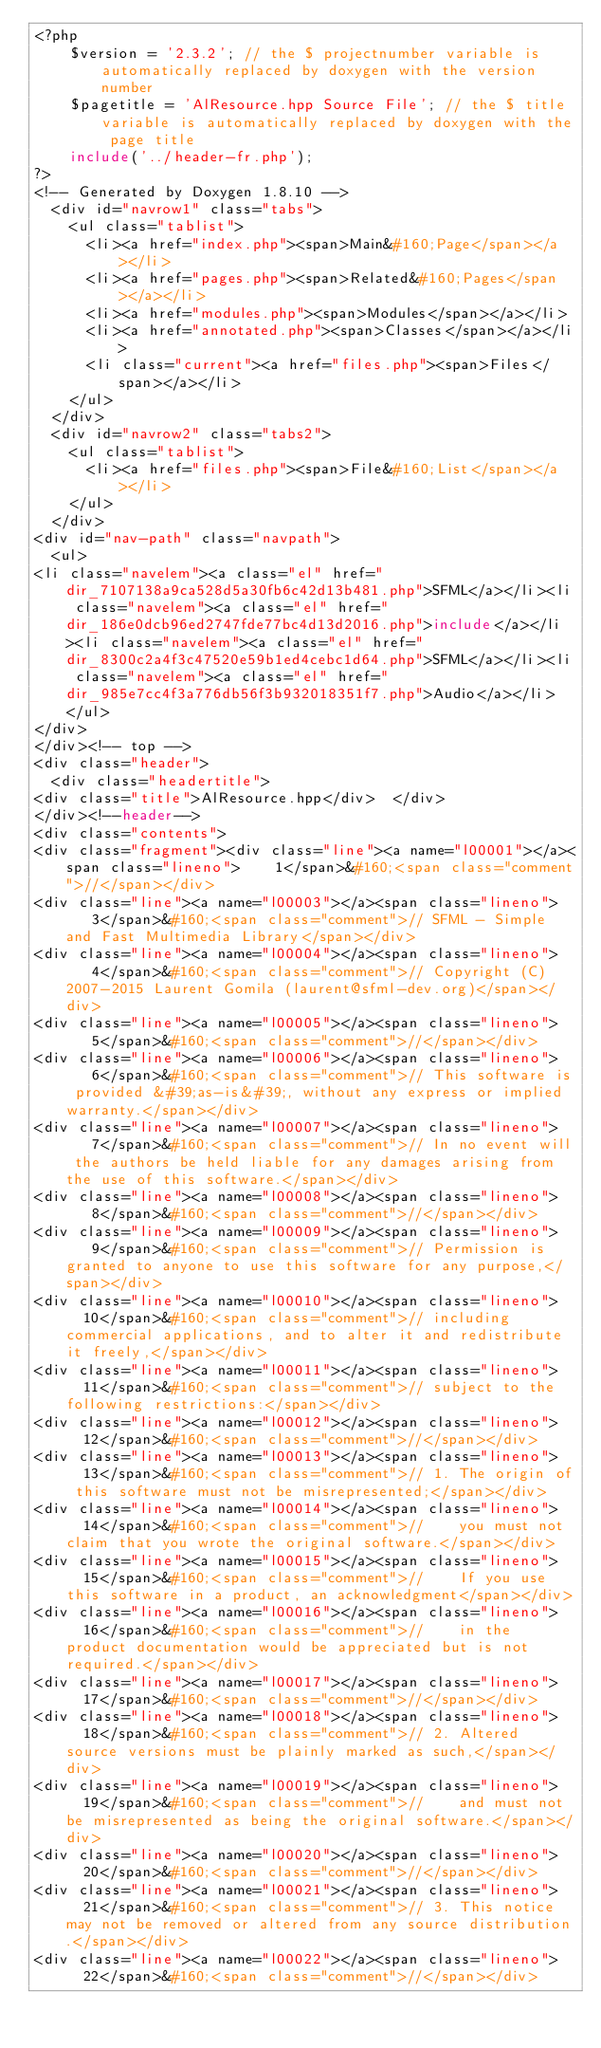Convert code to text. <code><loc_0><loc_0><loc_500><loc_500><_PHP_><?php
    $version = '2.3.2'; // the $ projectnumber variable is automatically replaced by doxygen with the version number
    $pagetitle = 'AlResource.hpp Source File'; // the $ title variable is automatically replaced by doxygen with the page title
    include('../header-fr.php');
?>
<!-- Generated by Doxygen 1.8.10 -->
  <div id="navrow1" class="tabs">
    <ul class="tablist">
      <li><a href="index.php"><span>Main&#160;Page</span></a></li>
      <li><a href="pages.php"><span>Related&#160;Pages</span></a></li>
      <li><a href="modules.php"><span>Modules</span></a></li>
      <li><a href="annotated.php"><span>Classes</span></a></li>
      <li class="current"><a href="files.php"><span>Files</span></a></li>
    </ul>
  </div>
  <div id="navrow2" class="tabs2">
    <ul class="tablist">
      <li><a href="files.php"><span>File&#160;List</span></a></li>
    </ul>
  </div>
<div id="nav-path" class="navpath">
  <ul>
<li class="navelem"><a class="el" href="dir_7107138a9ca528d5a30fb6c42d13b481.php">SFML</a></li><li class="navelem"><a class="el" href="dir_186e0dcb96ed2747fde77bc4d13d2016.php">include</a></li><li class="navelem"><a class="el" href="dir_8300c2a4f3c47520e59b1ed4cebc1d64.php">SFML</a></li><li class="navelem"><a class="el" href="dir_985e7cc4f3a776db56f3b932018351f7.php">Audio</a></li>  </ul>
</div>
</div><!-- top -->
<div class="header">
  <div class="headertitle">
<div class="title">AlResource.hpp</div>  </div>
</div><!--header-->
<div class="contents">
<div class="fragment"><div class="line"><a name="l00001"></a><span class="lineno">    1</span>&#160;<span class="comment">//</span></div>
<div class="line"><a name="l00003"></a><span class="lineno">    3</span>&#160;<span class="comment">// SFML - Simple and Fast Multimedia Library</span></div>
<div class="line"><a name="l00004"></a><span class="lineno">    4</span>&#160;<span class="comment">// Copyright (C) 2007-2015 Laurent Gomila (laurent@sfml-dev.org)</span></div>
<div class="line"><a name="l00005"></a><span class="lineno">    5</span>&#160;<span class="comment">//</span></div>
<div class="line"><a name="l00006"></a><span class="lineno">    6</span>&#160;<span class="comment">// This software is provided &#39;as-is&#39;, without any express or implied warranty.</span></div>
<div class="line"><a name="l00007"></a><span class="lineno">    7</span>&#160;<span class="comment">// In no event will the authors be held liable for any damages arising from the use of this software.</span></div>
<div class="line"><a name="l00008"></a><span class="lineno">    8</span>&#160;<span class="comment">//</span></div>
<div class="line"><a name="l00009"></a><span class="lineno">    9</span>&#160;<span class="comment">// Permission is granted to anyone to use this software for any purpose,</span></div>
<div class="line"><a name="l00010"></a><span class="lineno">   10</span>&#160;<span class="comment">// including commercial applications, and to alter it and redistribute it freely,</span></div>
<div class="line"><a name="l00011"></a><span class="lineno">   11</span>&#160;<span class="comment">// subject to the following restrictions:</span></div>
<div class="line"><a name="l00012"></a><span class="lineno">   12</span>&#160;<span class="comment">//</span></div>
<div class="line"><a name="l00013"></a><span class="lineno">   13</span>&#160;<span class="comment">// 1. The origin of this software must not be misrepresented;</span></div>
<div class="line"><a name="l00014"></a><span class="lineno">   14</span>&#160;<span class="comment">//    you must not claim that you wrote the original software.</span></div>
<div class="line"><a name="l00015"></a><span class="lineno">   15</span>&#160;<span class="comment">//    If you use this software in a product, an acknowledgment</span></div>
<div class="line"><a name="l00016"></a><span class="lineno">   16</span>&#160;<span class="comment">//    in the product documentation would be appreciated but is not required.</span></div>
<div class="line"><a name="l00017"></a><span class="lineno">   17</span>&#160;<span class="comment">//</span></div>
<div class="line"><a name="l00018"></a><span class="lineno">   18</span>&#160;<span class="comment">// 2. Altered source versions must be plainly marked as such,</span></div>
<div class="line"><a name="l00019"></a><span class="lineno">   19</span>&#160;<span class="comment">//    and must not be misrepresented as being the original software.</span></div>
<div class="line"><a name="l00020"></a><span class="lineno">   20</span>&#160;<span class="comment">//</span></div>
<div class="line"><a name="l00021"></a><span class="lineno">   21</span>&#160;<span class="comment">// 3. This notice may not be removed or altered from any source distribution.</span></div>
<div class="line"><a name="l00022"></a><span class="lineno">   22</span>&#160;<span class="comment">//</span></div></code> 